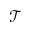Convert formula to latex. <formula><loc_0><loc_0><loc_500><loc_500>\mathcal { T }</formula> 